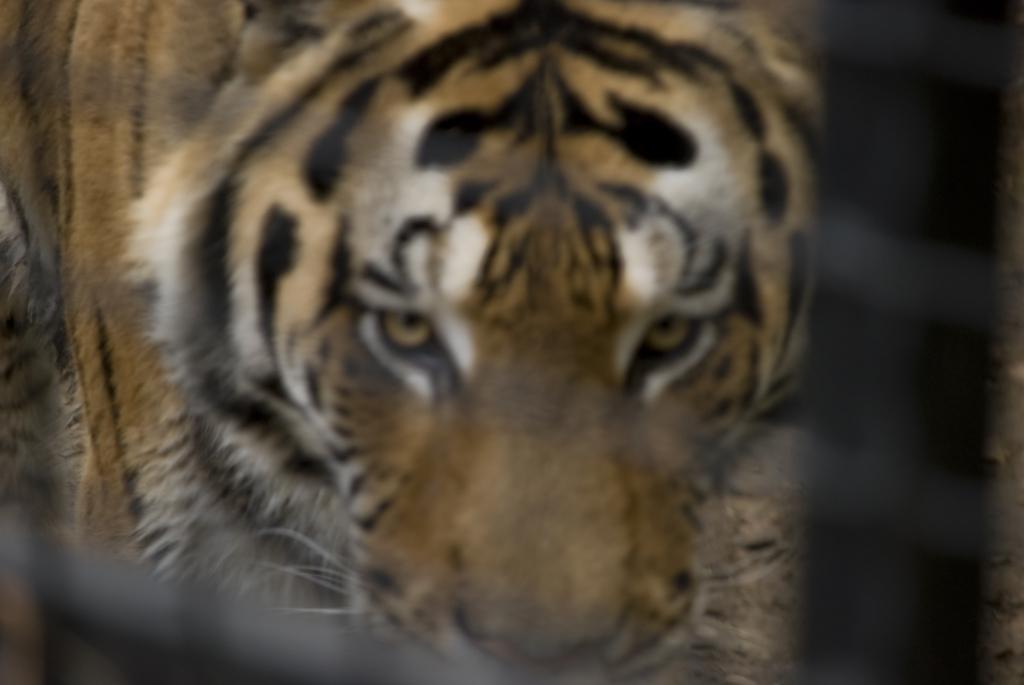Describe this image in one or two sentences. In this image I can see a tiger. 